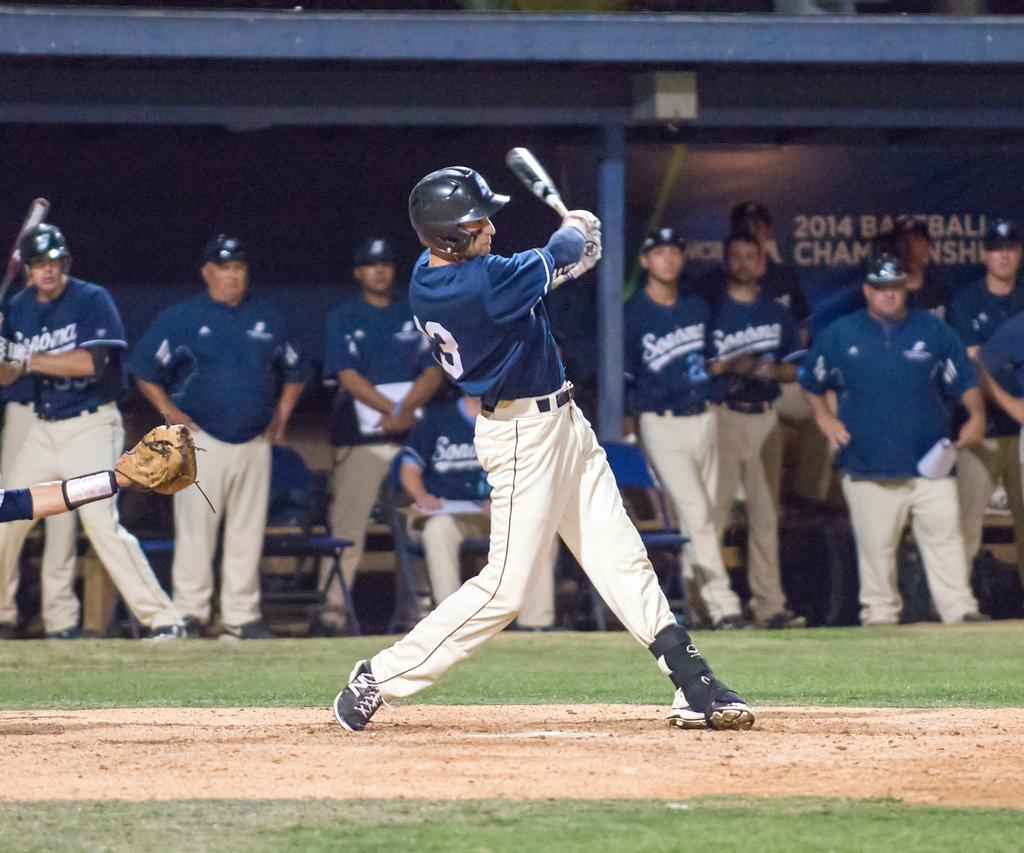<image>
Summarize the visual content of the image. As a bater swings the number 3 is visible on the back of their uniform. 